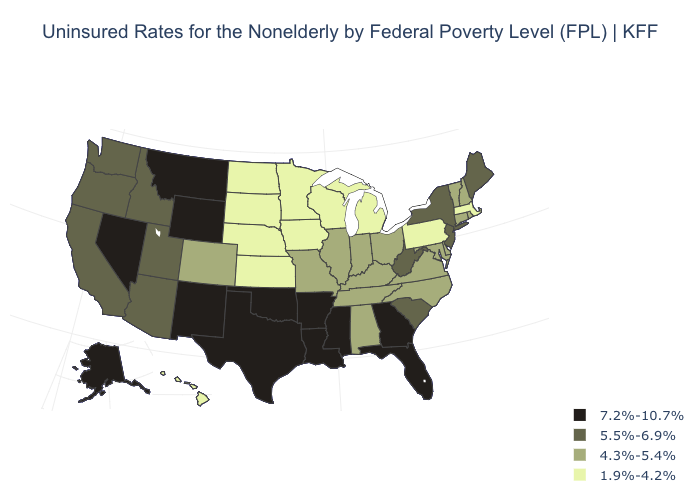Among the states that border California , does Nevada have the highest value?
Answer briefly. Yes. What is the value of Wyoming?
Answer briefly. 7.2%-10.7%. Name the states that have a value in the range 7.2%-10.7%?
Quick response, please. Alaska, Arkansas, Florida, Georgia, Louisiana, Mississippi, Montana, Nevada, New Mexico, Oklahoma, Texas, Wyoming. What is the lowest value in states that border California?
Concise answer only. 5.5%-6.9%. What is the value of Ohio?
Write a very short answer. 4.3%-5.4%. What is the lowest value in the Northeast?
Write a very short answer. 1.9%-4.2%. Which states have the lowest value in the Northeast?
Be succinct. Massachusetts, Pennsylvania. Name the states that have a value in the range 4.3%-5.4%?
Be succinct. Alabama, Colorado, Connecticut, Delaware, Illinois, Indiana, Kentucky, Maryland, Missouri, New Hampshire, North Carolina, Ohio, Rhode Island, Tennessee, Vermont, Virginia. What is the lowest value in the Northeast?
Be succinct. 1.9%-4.2%. What is the highest value in the Northeast ?
Quick response, please. 5.5%-6.9%. Name the states that have a value in the range 7.2%-10.7%?
Quick response, please. Alaska, Arkansas, Florida, Georgia, Louisiana, Mississippi, Montana, Nevada, New Mexico, Oklahoma, Texas, Wyoming. Name the states that have a value in the range 1.9%-4.2%?
Answer briefly. Hawaii, Iowa, Kansas, Massachusetts, Michigan, Minnesota, Nebraska, North Dakota, Pennsylvania, South Dakota, Wisconsin. Name the states that have a value in the range 4.3%-5.4%?
Be succinct. Alabama, Colorado, Connecticut, Delaware, Illinois, Indiana, Kentucky, Maryland, Missouri, New Hampshire, North Carolina, Ohio, Rhode Island, Tennessee, Vermont, Virginia. What is the value of New Mexico?
Answer briefly. 7.2%-10.7%. What is the value of New Jersey?
Quick response, please. 5.5%-6.9%. 